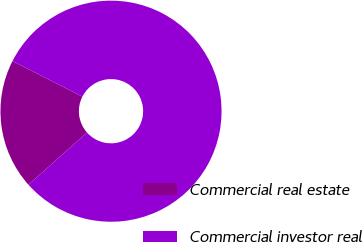Convert chart to OTSL. <chart><loc_0><loc_0><loc_500><loc_500><pie_chart><fcel>Commercial real estate<fcel>Commercial investor real<nl><fcel>19.07%<fcel>80.93%<nl></chart> 